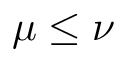Convert formula to latex. <formula><loc_0><loc_0><loc_500><loc_500>\mu \leq \nu</formula> 